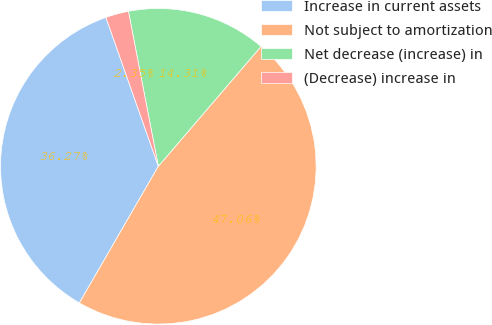<chart> <loc_0><loc_0><loc_500><loc_500><pie_chart><fcel>Increase in current assets<fcel>Not subject to amortization<fcel>Net decrease (increase) in<fcel>(Decrease) increase in<nl><fcel>36.27%<fcel>47.06%<fcel>14.31%<fcel>2.35%<nl></chart> 